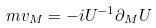Convert formula to latex. <formula><loc_0><loc_0><loc_500><loc_500>m v _ { M } = - i U ^ { - 1 } \partial _ { M } U</formula> 